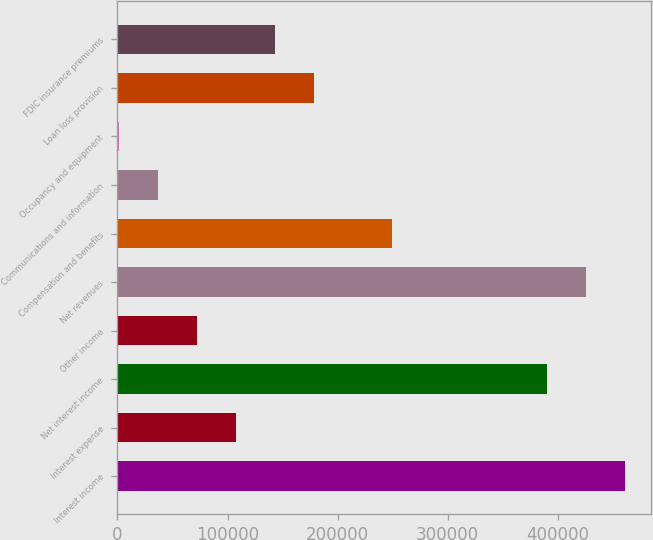Convert chart to OTSL. <chart><loc_0><loc_0><loc_500><loc_500><bar_chart><fcel>Interest income<fcel>Interest expense<fcel>Net interest income<fcel>Other income<fcel>Net revenues<fcel>Compensation and benefits<fcel>Communications and information<fcel>Occupancy and equipment<fcel>Loan loss provision<fcel>FDIC insurance premiums<nl><fcel>461513<fcel>107483<fcel>390707<fcel>72080<fcel>426110<fcel>249095<fcel>36677<fcel>1274<fcel>178289<fcel>142886<nl></chart> 